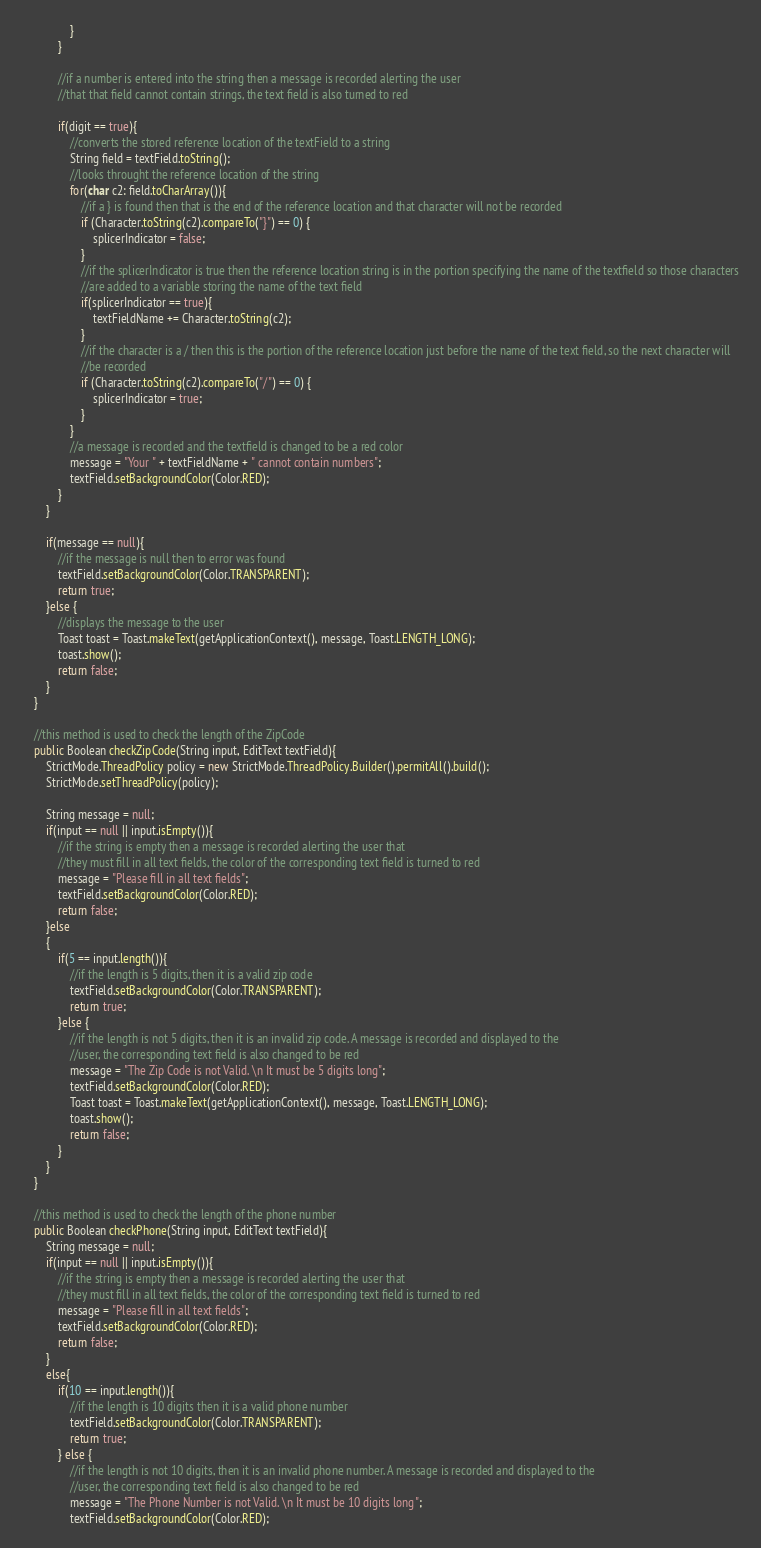Convert code to text. <code><loc_0><loc_0><loc_500><loc_500><_Java_>                }
            }

            //if a number is entered into the string then a message is recorded alerting the user
            //that that field cannot contain strings, the text field is also turned to red

            if(digit == true){
                //converts the stored reference location of the textField to a string
                String field = textField.toString();
                //looks throught the reference location of the string
                for(char c2: field.toCharArray()){
                    //if a } is found then that is the end of the reference location and that character will not be recorded
                    if (Character.toString(c2).compareTo("}") == 0) {
                        splicerIndicator = false;
                    }
                    //if the splicerIndicator is true then the reference location string is in the portion specifying the name of the textfield so those characters
                    //are added to a variable storing the name of the text field
                    if(splicerIndicator == true){
                        textFieldName += Character.toString(c2);
                    }
                    //if the character is a / then this is the portion of the reference location just before the name of the text field, so the next character will
                    //be recorded
                    if (Character.toString(c2).compareTo("/") == 0) {
                        splicerIndicator = true;
                    }
                }
                //a message is recorded and the textfield is changed to be a red color
                message = "Your " + textFieldName + " cannot contain numbers";
                textField.setBackgroundColor(Color.RED);
            }
        }

        if(message == null){
            //if the message is null then to error was found
            textField.setBackgroundColor(Color.TRANSPARENT);
            return true;
        }else {
            //displays the message to the user
            Toast toast = Toast.makeText(getApplicationContext(), message, Toast.LENGTH_LONG);
            toast.show();
            return false;
        }
    }

    //this method is used to check the length of the ZipCode
    public Boolean checkZipCode(String input, EditText textField){
        StrictMode.ThreadPolicy policy = new StrictMode.ThreadPolicy.Builder().permitAll().build();
        StrictMode.setThreadPolicy(policy);

        String message = null;
        if(input == null || input.isEmpty()){
            //if the string is empty then a message is recorded alerting the user that
            //they must fill in all text fields, the color of the corresponding text field is turned to red
            message = "Please fill in all text fields";
            textField.setBackgroundColor(Color.RED);
            return false;
        }else
        {
            if(5 == input.length()){
                //if the length is 5 digits, then it is a valid zip code
                textField.setBackgroundColor(Color.TRANSPARENT);
                return true;
            }else {
                //if the length is not 5 digits, then it is an invalid zip code. A message is recorded and displayed to the
                //user, the corresponding text field is also changed to be red
                message = "The Zip Code is not Valid. \n It must be 5 digits long";
                textField.setBackgroundColor(Color.RED);
                Toast toast = Toast.makeText(getApplicationContext(), message, Toast.LENGTH_LONG);
                toast.show();
                return false;
            }
        }
    }

    //this method is used to check the length of the phone number
    public Boolean checkPhone(String input, EditText textField){
        String message = null;
        if(input == null || input.isEmpty()){
            //if the string is empty then a message is recorded alerting the user that
            //they must fill in all text fields, the color of the corresponding text field is turned to red
            message = "Please fill in all text fields";
            textField.setBackgroundColor(Color.RED);
            return false;
        }
        else{
            if(10 == input.length()){
                //if the length is 10 digits then it is a valid phone number
                textField.setBackgroundColor(Color.TRANSPARENT);
                return true;
            } else {
                //if the length is not 10 digits, then it is an invalid phone number. A message is recorded and displayed to the
                //user, the corresponding text field is also changed to be red
                message = "The Phone Number is not Valid. \n It must be 10 digits long";
                textField.setBackgroundColor(Color.RED);</code> 